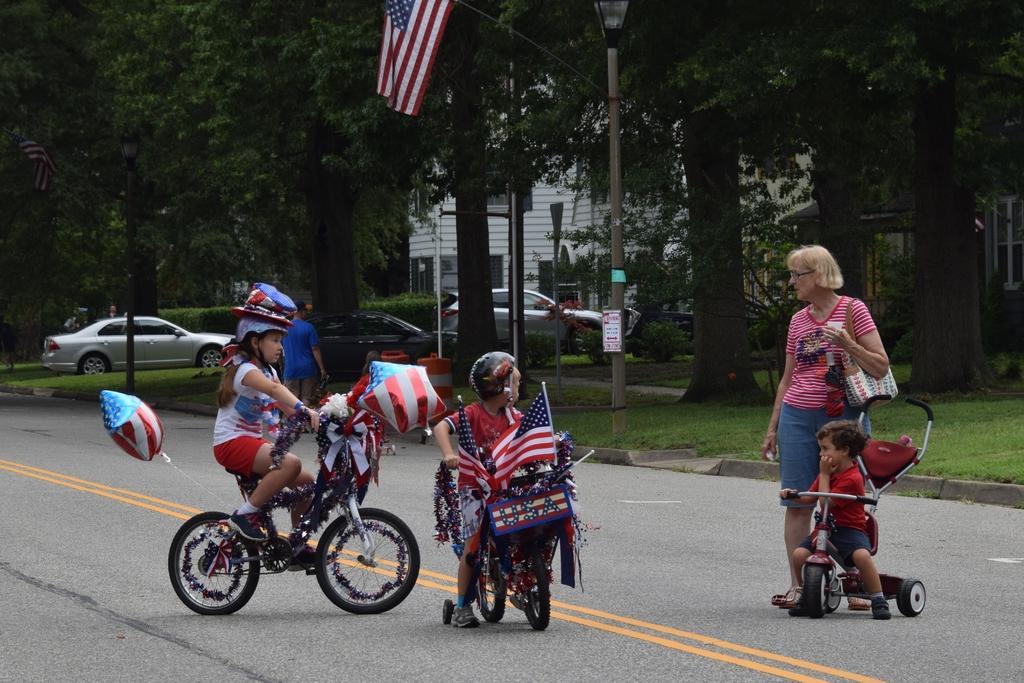Please provide a concise description of this image. In this picture we can see two kids on the bicycles. This is road. Here we can see a woman standing on the road. There is a vehicle and this is grass. On the background we can see some trees and this is pole. There is a building and this is flag. 